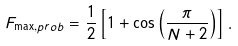Convert formula to latex. <formula><loc_0><loc_0><loc_500><loc_500>F _ { \max , p r o b } = \frac { 1 } { 2 } \left [ 1 + \cos \left ( \frac { \pi } { N + 2 } \right ) \right ] .</formula> 